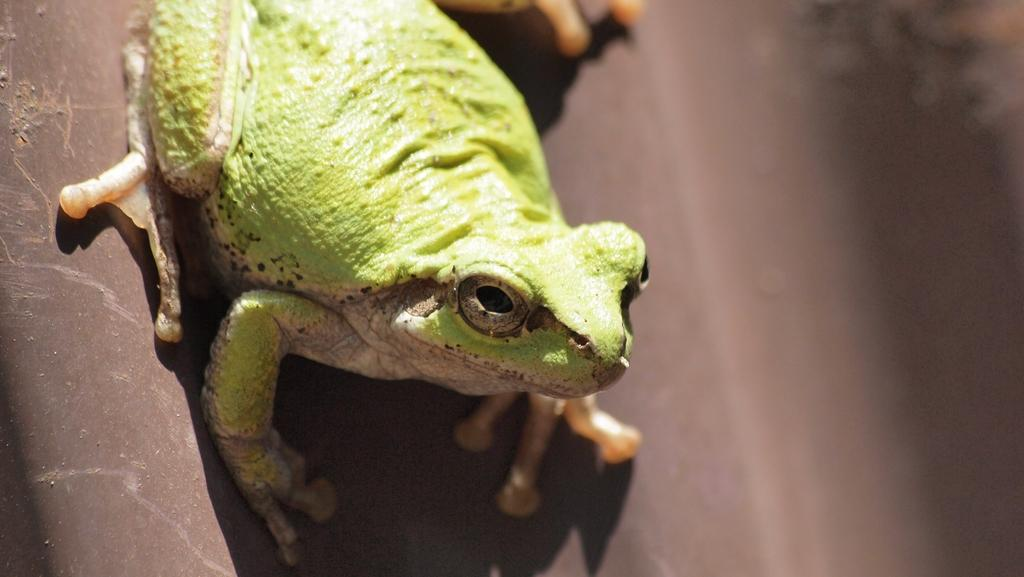What animal is present in the picture? There is a frog in the picture. What is the color of the frog? The frog is green in color. What is the color of the background in the picture? The background of the picture is brown. What type of bag is the frog carrying in the picture? There is no bag present in the picture, as the image features a frog and does not show any bags or other accessories. 